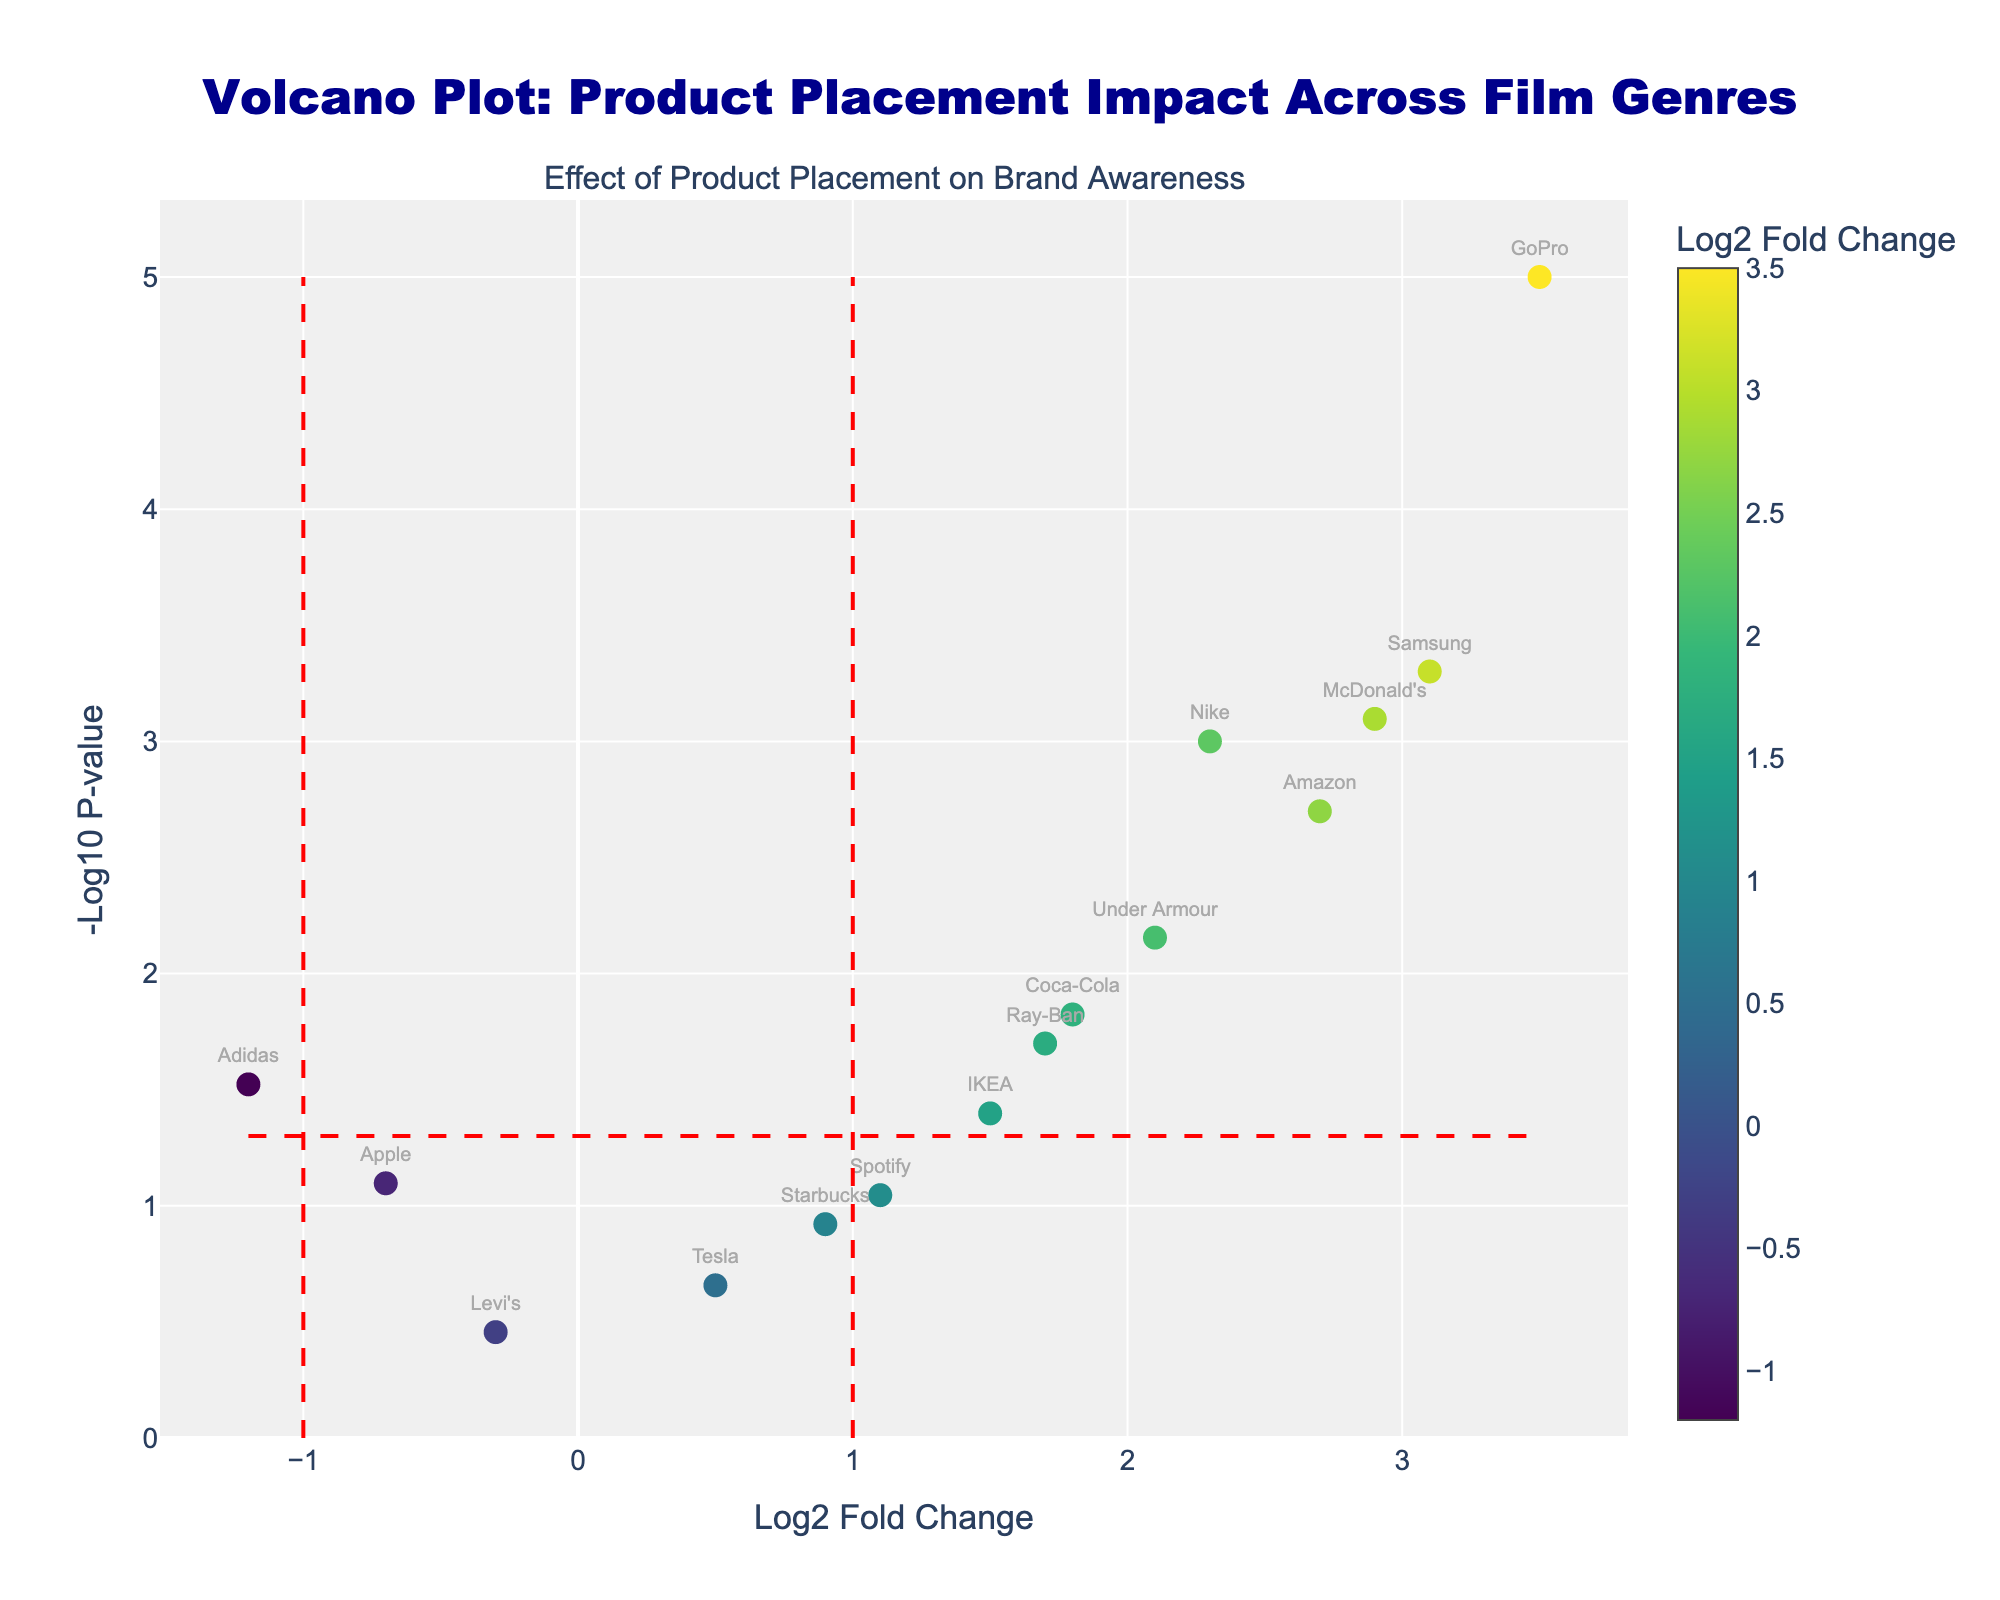What's the title of the plot? The title is located at the top of the plot and describes the main theme of the visualization.
Answer: Volcano Plot: Product Placement Impact Across Film Genres What do the axes represent in the plot? The x-axis represents the Log2 Fold Change, and the y-axis represents the -Log10 P-value.
Answer: Log2 Fold Change and -Log10 P-value Which brand in the figure is associated with Sci-Fi genre? By looking at the hover text or labels near the data points, you can identify that Samsung is associated with Sci-Fi genre.
Answer: Samsung How many data points in the figure have a p-value less than 0.05? To find this, locate the horizontal line representing -log10(0.05) and count the data points above this line. There are 9 data points above this threshold.
Answer: 9 What is the Log2 Fold Change for the brand associated with the Adventure genre? The hover text or labels reveal that GoPro is the brand for Adventure genre, with a Log2 Fold Change of 3.5.
Answer: 3.5 Which brand has the highest positive Log2 Fold Change? By locating the rightmost data point on the x-axis, we identify that GoPro has the highest positive Log2 Fold Change at 3.5.
Answer: GoPro Between Comedy and Horror genres, which brand shows a greater Log2 Fold Change? Comparing the Log2 Fold Change values, Coca-Cola (Comedy) has a value of 1.8, and Adidas (Horror) has a value of -1.2. Since 1.8 > -1.2, Coca-Cola shows a greater Log2 Fold Change.
Answer: Coca-Cola How does the placement of Apple in Drama genre compare to Samsung in Sci-Fi genre in terms of Log2 Fold Change? Apple's Log2 Fold Change is -0.7, while Samsung's is 3.1. Samsung has a much higher positive Log2 Fold Change compared to Apple.
Answer: Samsung has higher Log2 Fold Change Which data point is closest to the Origin (0,0)? Calculate the distance of each data point from the origin and find the minimum. Tesla in Documentary genre with coordinates (0.5, 0.66) is closest to the origin.
Answer: Tesla 